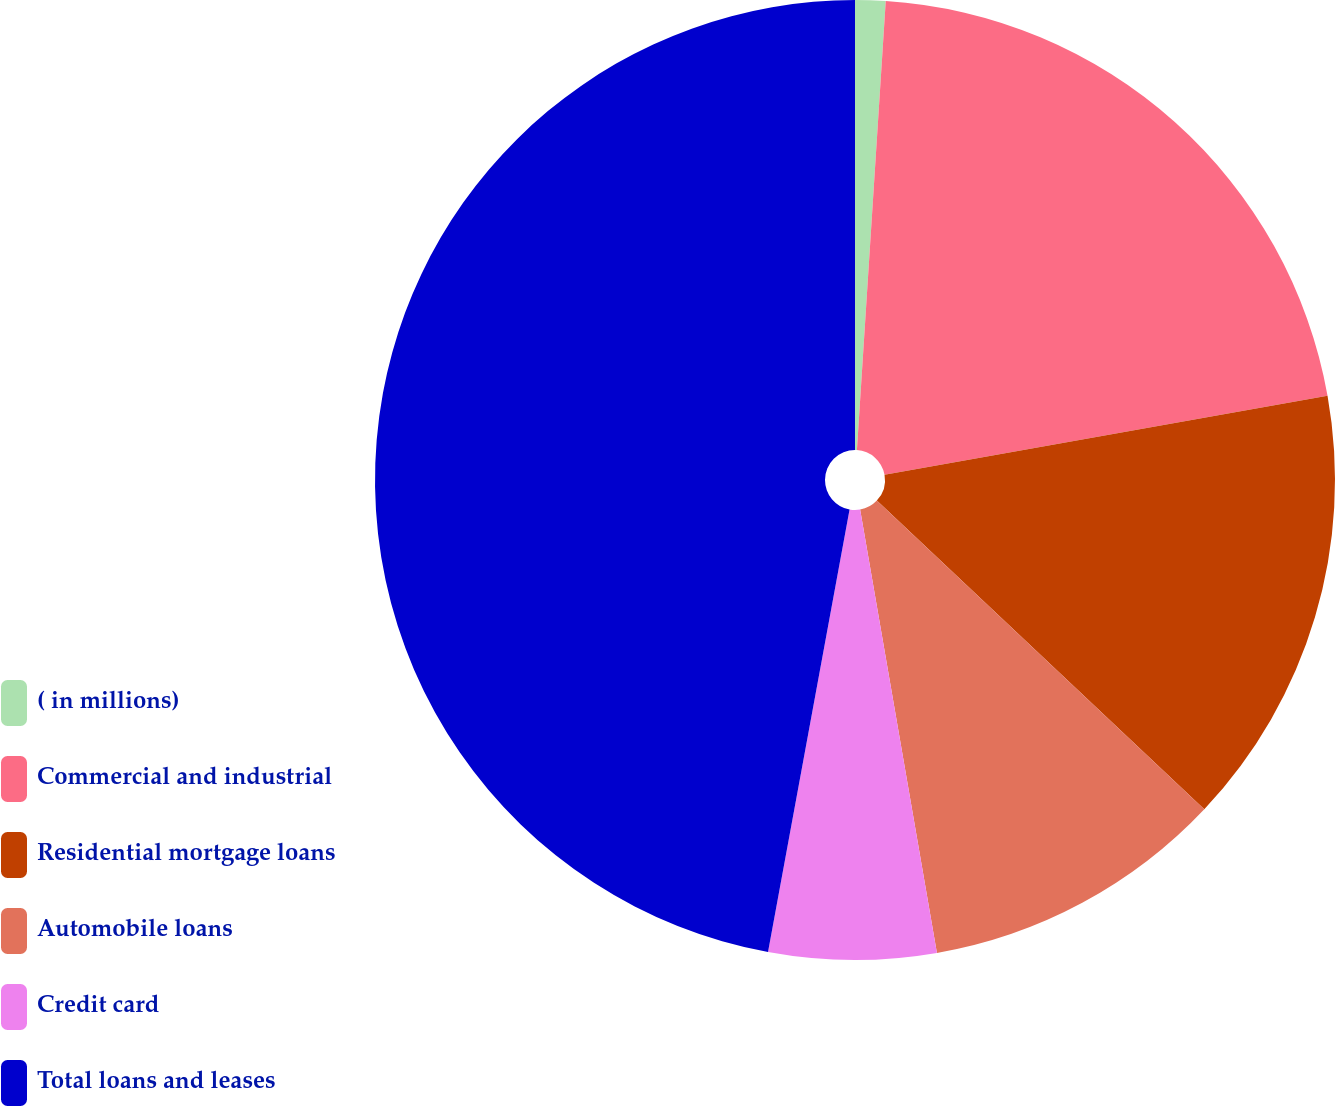<chart> <loc_0><loc_0><loc_500><loc_500><pie_chart><fcel>( in millions)<fcel>Commercial and industrial<fcel>Residential mortgage loans<fcel>Automobile loans<fcel>Credit card<fcel>Total loans and leases<nl><fcel>1.02%<fcel>21.17%<fcel>14.84%<fcel>10.24%<fcel>5.63%<fcel>47.1%<nl></chart> 